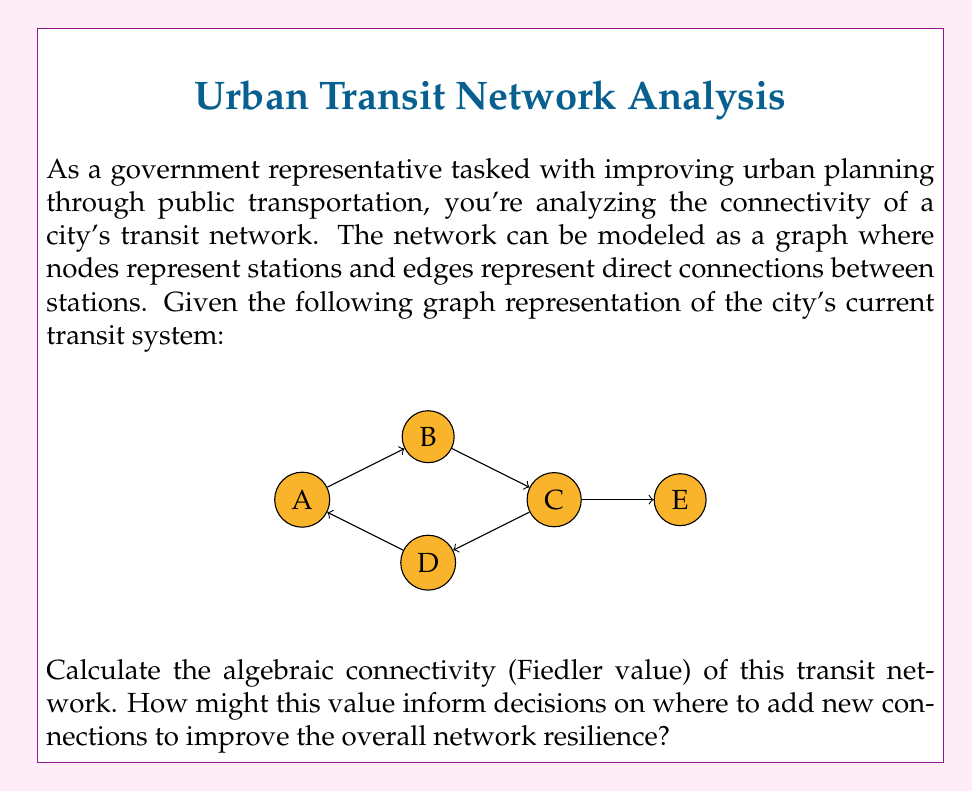Help me with this question. To solve this problem, we'll follow these steps:

1) First, we need to construct the Laplacian matrix of the graph. The Laplacian matrix $L$ is defined as $L = D - A$, where $D$ is the degree matrix and $A$ is the adjacency matrix.

2) For this graph:
   $D = \begin{bmatrix}
   3 & 0 & 0 & 0 & 0\\
   0 & 3 & 0 & 0 & 0\\
   0 & 0 & 4 & 0 & 0\\
   0 & 0 & 0 & 3 & 0\\
   0 & 0 & 0 & 0 & 1
   \end{bmatrix}$

   $A = \begin{bmatrix}
   0 & 1 & 0 & 1 & 0\\
   1 & 0 & 1 & 1 & 0\\
   0 & 1 & 0 & 1 & 1\\
   1 & 1 & 1 & 0 & 0\\
   0 & 0 & 1 & 0 & 0
   \end{bmatrix}$

3) Therefore, the Laplacian matrix $L$ is:
   $L = D - A = \begin{bmatrix}
   3 & -1 & 0 & -1 & 0\\
   -1 & 3 & -1 & -1 & 0\\
   0 & -1 & 4 & -1 & -1\\
   -1 & -1 & -1 & 3 & 0\\
   0 & 0 & -1 & 0 & 1
   \end{bmatrix}$

4) The algebraic connectivity (Fiedler value) is the second smallest eigenvalue of $L$.

5) Calculating the eigenvalues of $L$ (which can be done using numerical methods or specialized software), we get:
   $\lambda_1 = 0$
   $\lambda_2 \approx 0.5188$
   $\lambda_3 \approx 2.0000$
   $\lambda_4 \approx 3.4812$
   $\lambda_5 \approx 6.0000$

6) The Fiedler value is $\lambda_2 \approx 0.5188$.

This value informs decisions on network improvement in several ways:

- A higher Fiedler value indicates better connectivity. The current value of 0.5188 is relatively low, suggesting room for improvement.
- Adding edges that increase this value would improve overall connectivity.
- Stations corresponding to the components of the Fiedler vector with the largest difference are good candidates for new connections.
- The low value also indicates the network's vulnerability to disconnection, emphasizing the need for redundant paths.

By strategically adding connections to increase the Fiedler value, planners can enhance the network's resilience and efficiency.
Answer: $0.5188$ 